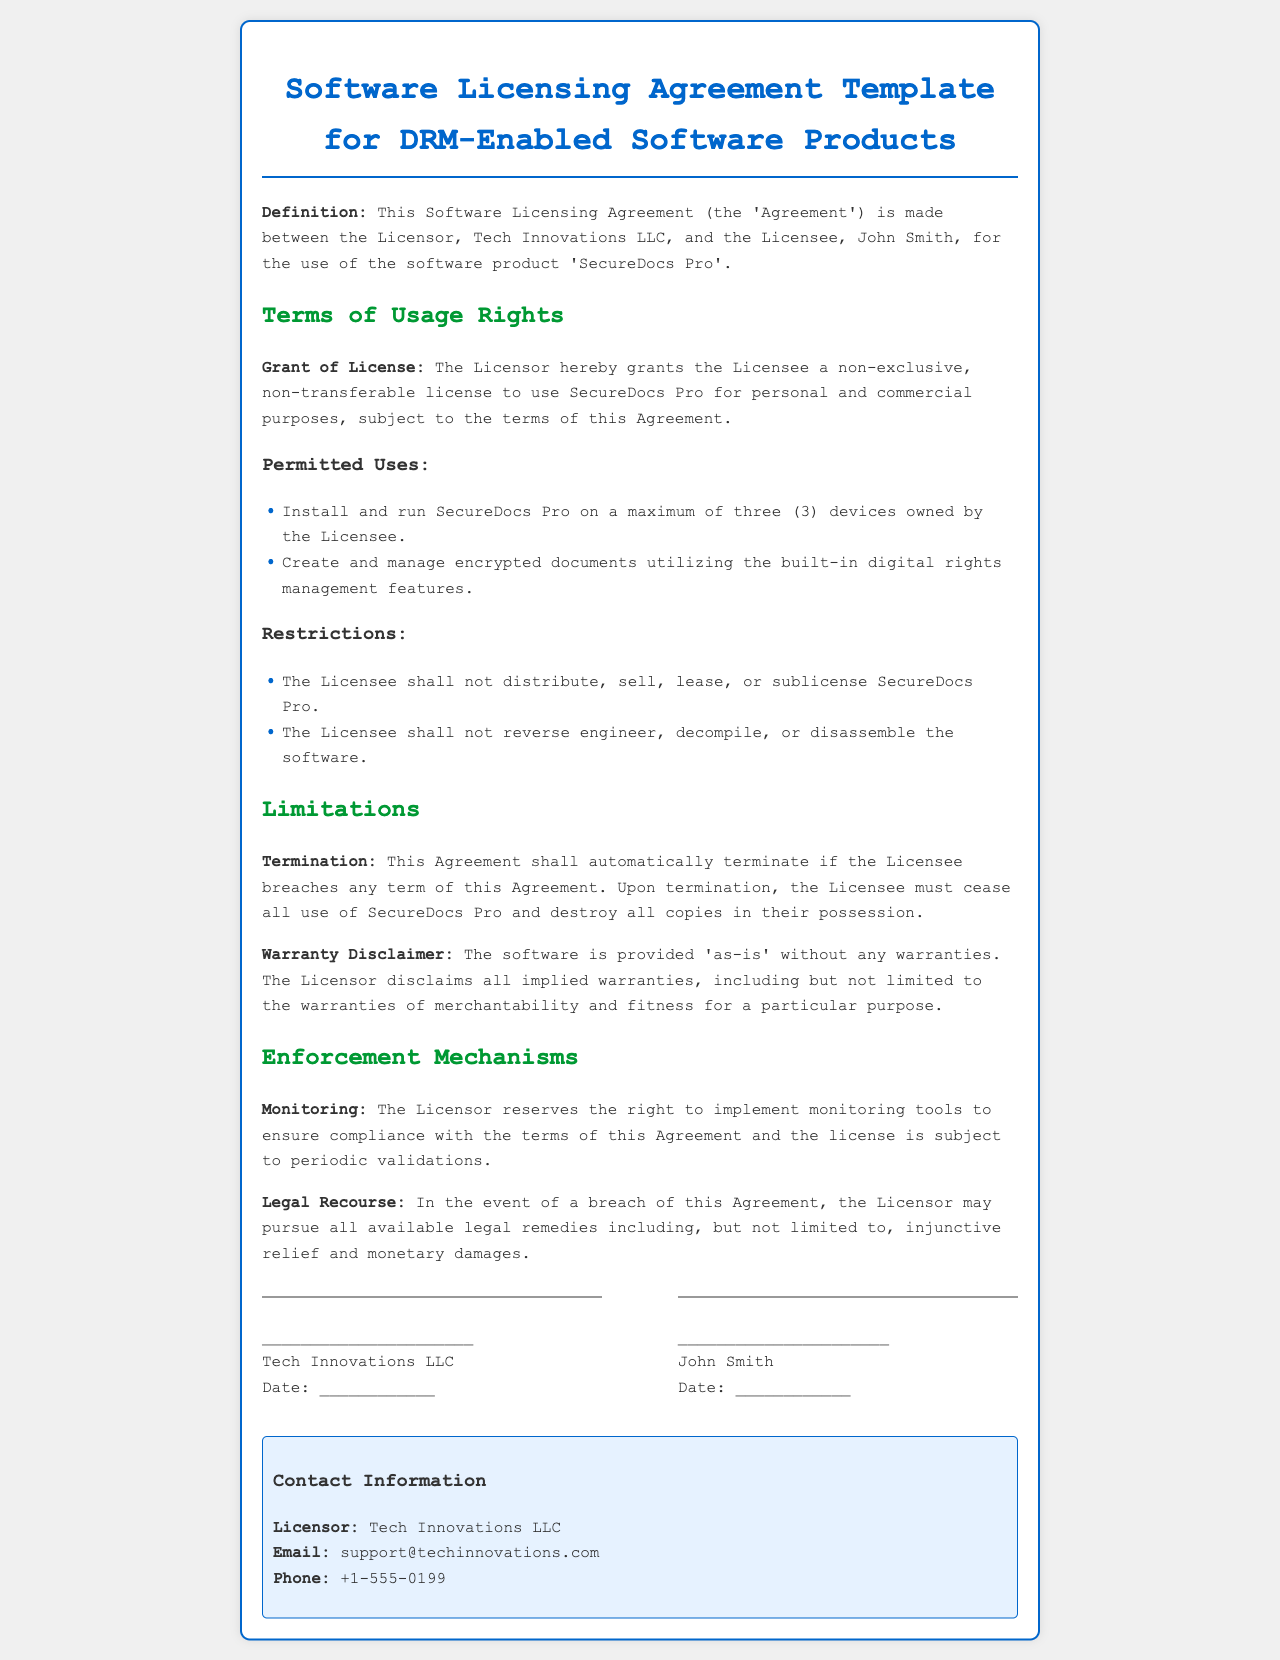What is the name of the software product? The document specifies the software product as 'SecureDocs Pro'.
Answer: SecureDocs Pro Who is the Licensor? The document identifies the Licensor as Tech Innovations LLC.
Answer: Tech Innovations LLC How many devices can the Licensee install the software on? The document states that the Licensee can install SecureDocs Pro on a maximum of three devices.
Answer: three (3) What happens if the Licensee breaches any term? The document indicates that the Agreement shall automatically terminate if the Licensee breaches any term.
Answer: automatically terminate What type of license is granted to the Licensee? The license granted is non-exclusive and non-transferable as stated in the document.
Answer: non-exclusive, non-transferable What is the warranty status of the software? The document declares that the software is provided 'as-is' without any warranties.
Answer: 'as-is' What legal recourse does the Licensor have in case of a breach? The document mentions that the Licensor may pursue all available legal remedies including injunctive relief and monetary damages.
Answer: injunctive relief and monetary damages What is one of the permitted uses of the software? The document allows the Licensee to create and manage encrypted documents utilizing the built-in digital rights management features.
Answer: create and manage encrypted documents When was the Agreement made? The document does not provide a specific date when the Agreement was made between the Licensor and Licensee.
Answer: ____________ (to be filled in) 